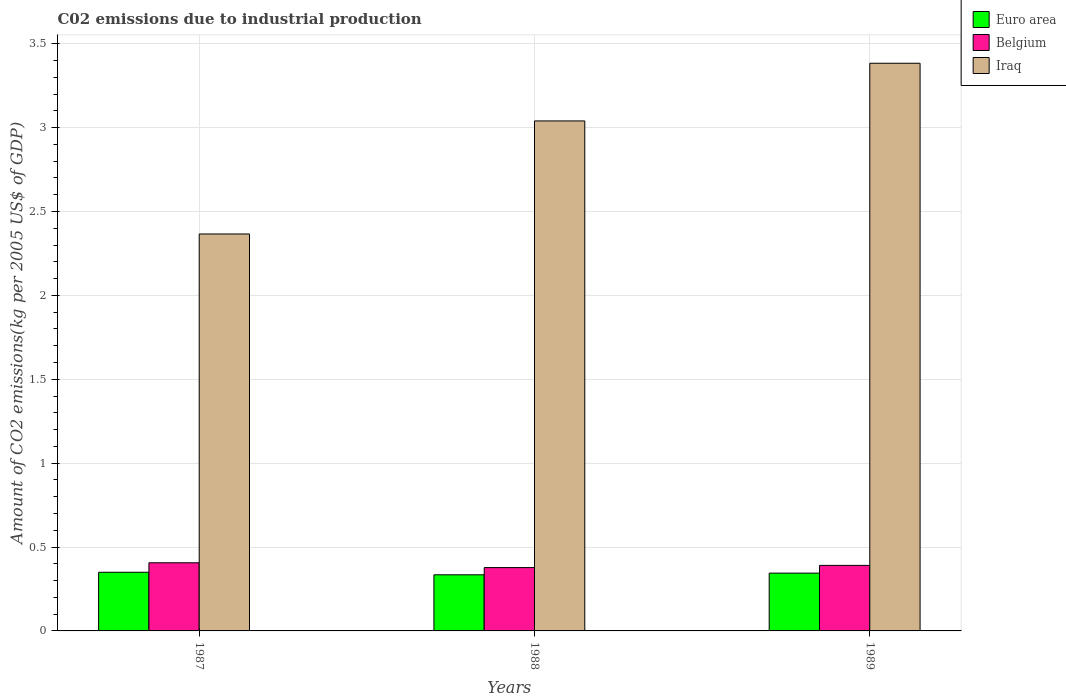Are the number of bars per tick equal to the number of legend labels?
Your response must be concise. Yes. In how many cases, is the number of bars for a given year not equal to the number of legend labels?
Provide a short and direct response. 0. What is the amount of CO2 emitted due to industrial production in Iraq in 1988?
Give a very brief answer. 3.04. Across all years, what is the maximum amount of CO2 emitted due to industrial production in Belgium?
Your answer should be very brief. 0.41. Across all years, what is the minimum amount of CO2 emitted due to industrial production in Iraq?
Provide a succinct answer. 2.37. In which year was the amount of CO2 emitted due to industrial production in Iraq maximum?
Ensure brevity in your answer.  1989. In which year was the amount of CO2 emitted due to industrial production in Iraq minimum?
Your response must be concise. 1987. What is the total amount of CO2 emitted due to industrial production in Belgium in the graph?
Your answer should be compact. 1.17. What is the difference between the amount of CO2 emitted due to industrial production in Iraq in 1987 and that in 1989?
Your response must be concise. -1.02. What is the difference between the amount of CO2 emitted due to industrial production in Iraq in 1988 and the amount of CO2 emitted due to industrial production in Belgium in 1989?
Keep it short and to the point. 2.65. What is the average amount of CO2 emitted due to industrial production in Belgium per year?
Your answer should be compact. 0.39. In the year 1988, what is the difference between the amount of CO2 emitted due to industrial production in Belgium and amount of CO2 emitted due to industrial production in Iraq?
Offer a terse response. -2.66. In how many years, is the amount of CO2 emitted due to industrial production in Iraq greater than 2.2 kg?
Ensure brevity in your answer.  3. What is the ratio of the amount of CO2 emitted due to industrial production in Belgium in 1987 to that in 1989?
Ensure brevity in your answer.  1.04. Is the difference between the amount of CO2 emitted due to industrial production in Belgium in 1988 and 1989 greater than the difference between the amount of CO2 emitted due to industrial production in Iraq in 1988 and 1989?
Provide a succinct answer. Yes. What is the difference between the highest and the second highest amount of CO2 emitted due to industrial production in Belgium?
Offer a terse response. 0.02. What is the difference between the highest and the lowest amount of CO2 emitted due to industrial production in Belgium?
Provide a succinct answer. 0.03. Is the sum of the amount of CO2 emitted due to industrial production in Iraq in 1988 and 1989 greater than the maximum amount of CO2 emitted due to industrial production in Belgium across all years?
Provide a succinct answer. Yes. What does the 3rd bar from the left in 1989 represents?
Offer a terse response. Iraq. What does the 1st bar from the right in 1989 represents?
Provide a short and direct response. Iraq. Is it the case that in every year, the sum of the amount of CO2 emitted due to industrial production in Euro area and amount of CO2 emitted due to industrial production in Belgium is greater than the amount of CO2 emitted due to industrial production in Iraq?
Your answer should be compact. No. How many bars are there?
Make the answer very short. 9. How many years are there in the graph?
Provide a succinct answer. 3. What is the difference between two consecutive major ticks on the Y-axis?
Make the answer very short. 0.5. Does the graph contain any zero values?
Offer a terse response. No. Does the graph contain grids?
Offer a very short reply. Yes. Where does the legend appear in the graph?
Your answer should be compact. Top right. How many legend labels are there?
Ensure brevity in your answer.  3. What is the title of the graph?
Your response must be concise. C02 emissions due to industrial production. Does "Trinidad and Tobago" appear as one of the legend labels in the graph?
Your response must be concise. No. What is the label or title of the Y-axis?
Keep it short and to the point. Amount of CO2 emissions(kg per 2005 US$ of GDP). What is the Amount of CO2 emissions(kg per 2005 US$ of GDP) of Euro area in 1987?
Provide a short and direct response. 0.35. What is the Amount of CO2 emissions(kg per 2005 US$ of GDP) in Belgium in 1987?
Provide a succinct answer. 0.41. What is the Amount of CO2 emissions(kg per 2005 US$ of GDP) in Iraq in 1987?
Give a very brief answer. 2.37. What is the Amount of CO2 emissions(kg per 2005 US$ of GDP) in Euro area in 1988?
Your response must be concise. 0.33. What is the Amount of CO2 emissions(kg per 2005 US$ of GDP) of Belgium in 1988?
Provide a short and direct response. 0.38. What is the Amount of CO2 emissions(kg per 2005 US$ of GDP) in Iraq in 1988?
Offer a terse response. 3.04. What is the Amount of CO2 emissions(kg per 2005 US$ of GDP) in Euro area in 1989?
Make the answer very short. 0.34. What is the Amount of CO2 emissions(kg per 2005 US$ of GDP) in Belgium in 1989?
Provide a succinct answer. 0.39. What is the Amount of CO2 emissions(kg per 2005 US$ of GDP) in Iraq in 1989?
Your response must be concise. 3.38. Across all years, what is the maximum Amount of CO2 emissions(kg per 2005 US$ of GDP) in Euro area?
Provide a short and direct response. 0.35. Across all years, what is the maximum Amount of CO2 emissions(kg per 2005 US$ of GDP) in Belgium?
Offer a terse response. 0.41. Across all years, what is the maximum Amount of CO2 emissions(kg per 2005 US$ of GDP) in Iraq?
Offer a very short reply. 3.38. Across all years, what is the minimum Amount of CO2 emissions(kg per 2005 US$ of GDP) in Euro area?
Keep it short and to the point. 0.33. Across all years, what is the minimum Amount of CO2 emissions(kg per 2005 US$ of GDP) of Belgium?
Your answer should be very brief. 0.38. Across all years, what is the minimum Amount of CO2 emissions(kg per 2005 US$ of GDP) in Iraq?
Provide a succinct answer. 2.37. What is the total Amount of CO2 emissions(kg per 2005 US$ of GDP) of Euro area in the graph?
Your answer should be compact. 1.03. What is the total Amount of CO2 emissions(kg per 2005 US$ of GDP) of Belgium in the graph?
Your answer should be compact. 1.17. What is the total Amount of CO2 emissions(kg per 2005 US$ of GDP) in Iraq in the graph?
Provide a succinct answer. 8.79. What is the difference between the Amount of CO2 emissions(kg per 2005 US$ of GDP) in Euro area in 1987 and that in 1988?
Your answer should be very brief. 0.02. What is the difference between the Amount of CO2 emissions(kg per 2005 US$ of GDP) of Belgium in 1987 and that in 1988?
Your answer should be very brief. 0.03. What is the difference between the Amount of CO2 emissions(kg per 2005 US$ of GDP) in Iraq in 1987 and that in 1988?
Provide a succinct answer. -0.67. What is the difference between the Amount of CO2 emissions(kg per 2005 US$ of GDP) in Euro area in 1987 and that in 1989?
Your response must be concise. 0.01. What is the difference between the Amount of CO2 emissions(kg per 2005 US$ of GDP) in Belgium in 1987 and that in 1989?
Your answer should be compact. 0.02. What is the difference between the Amount of CO2 emissions(kg per 2005 US$ of GDP) of Iraq in 1987 and that in 1989?
Your response must be concise. -1.02. What is the difference between the Amount of CO2 emissions(kg per 2005 US$ of GDP) in Euro area in 1988 and that in 1989?
Your answer should be compact. -0.01. What is the difference between the Amount of CO2 emissions(kg per 2005 US$ of GDP) in Belgium in 1988 and that in 1989?
Your answer should be compact. -0.01. What is the difference between the Amount of CO2 emissions(kg per 2005 US$ of GDP) of Iraq in 1988 and that in 1989?
Your response must be concise. -0.34. What is the difference between the Amount of CO2 emissions(kg per 2005 US$ of GDP) of Euro area in 1987 and the Amount of CO2 emissions(kg per 2005 US$ of GDP) of Belgium in 1988?
Offer a terse response. -0.03. What is the difference between the Amount of CO2 emissions(kg per 2005 US$ of GDP) in Euro area in 1987 and the Amount of CO2 emissions(kg per 2005 US$ of GDP) in Iraq in 1988?
Offer a very short reply. -2.69. What is the difference between the Amount of CO2 emissions(kg per 2005 US$ of GDP) in Belgium in 1987 and the Amount of CO2 emissions(kg per 2005 US$ of GDP) in Iraq in 1988?
Your answer should be very brief. -2.63. What is the difference between the Amount of CO2 emissions(kg per 2005 US$ of GDP) in Euro area in 1987 and the Amount of CO2 emissions(kg per 2005 US$ of GDP) in Belgium in 1989?
Make the answer very short. -0.04. What is the difference between the Amount of CO2 emissions(kg per 2005 US$ of GDP) in Euro area in 1987 and the Amount of CO2 emissions(kg per 2005 US$ of GDP) in Iraq in 1989?
Provide a succinct answer. -3.03. What is the difference between the Amount of CO2 emissions(kg per 2005 US$ of GDP) of Belgium in 1987 and the Amount of CO2 emissions(kg per 2005 US$ of GDP) of Iraq in 1989?
Your answer should be compact. -2.98. What is the difference between the Amount of CO2 emissions(kg per 2005 US$ of GDP) in Euro area in 1988 and the Amount of CO2 emissions(kg per 2005 US$ of GDP) in Belgium in 1989?
Provide a short and direct response. -0.06. What is the difference between the Amount of CO2 emissions(kg per 2005 US$ of GDP) in Euro area in 1988 and the Amount of CO2 emissions(kg per 2005 US$ of GDP) in Iraq in 1989?
Provide a succinct answer. -3.05. What is the difference between the Amount of CO2 emissions(kg per 2005 US$ of GDP) of Belgium in 1988 and the Amount of CO2 emissions(kg per 2005 US$ of GDP) of Iraq in 1989?
Make the answer very short. -3.01. What is the average Amount of CO2 emissions(kg per 2005 US$ of GDP) in Euro area per year?
Your answer should be compact. 0.34. What is the average Amount of CO2 emissions(kg per 2005 US$ of GDP) of Belgium per year?
Your response must be concise. 0.39. What is the average Amount of CO2 emissions(kg per 2005 US$ of GDP) in Iraq per year?
Keep it short and to the point. 2.93. In the year 1987, what is the difference between the Amount of CO2 emissions(kg per 2005 US$ of GDP) in Euro area and Amount of CO2 emissions(kg per 2005 US$ of GDP) in Belgium?
Your answer should be very brief. -0.06. In the year 1987, what is the difference between the Amount of CO2 emissions(kg per 2005 US$ of GDP) in Euro area and Amount of CO2 emissions(kg per 2005 US$ of GDP) in Iraq?
Provide a short and direct response. -2.02. In the year 1987, what is the difference between the Amount of CO2 emissions(kg per 2005 US$ of GDP) of Belgium and Amount of CO2 emissions(kg per 2005 US$ of GDP) of Iraq?
Your answer should be compact. -1.96. In the year 1988, what is the difference between the Amount of CO2 emissions(kg per 2005 US$ of GDP) in Euro area and Amount of CO2 emissions(kg per 2005 US$ of GDP) in Belgium?
Keep it short and to the point. -0.04. In the year 1988, what is the difference between the Amount of CO2 emissions(kg per 2005 US$ of GDP) of Euro area and Amount of CO2 emissions(kg per 2005 US$ of GDP) of Iraq?
Offer a terse response. -2.71. In the year 1988, what is the difference between the Amount of CO2 emissions(kg per 2005 US$ of GDP) of Belgium and Amount of CO2 emissions(kg per 2005 US$ of GDP) of Iraq?
Your answer should be very brief. -2.66. In the year 1989, what is the difference between the Amount of CO2 emissions(kg per 2005 US$ of GDP) of Euro area and Amount of CO2 emissions(kg per 2005 US$ of GDP) of Belgium?
Provide a succinct answer. -0.05. In the year 1989, what is the difference between the Amount of CO2 emissions(kg per 2005 US$ of GDP) of Euro area and Amount of CO2 emissions(kg per 2005 US$ of GDP) of Iraq?
Provide a succinct answer. -3.04. In the year 1989, what is the difference between the Amount of CO2 emissions(kg per 2005 US$ of GDP) of Belgium and Amount of CO2 emissions(kg per 2005 US$ of GDP) of Iraq?
Offer a terse response. -2.99. What is the ratio of the Amount of CO2 emissions(kg per 2005 US$ of GDP) of Euro area in 1987 to that in 1988?
Ensure brevity in your answer.  1.05. What is the ratio of the Amount of CO2 emissions(kg per 2005 US$ of GDP) of Belgium in 1987 to that in 1988?
Your answer should be very brief. 1.08. What is the ratio of the Amount of CO2 emissions(kg per 2005 US$ of GDP) in Iraq in 1987 to that in 1988?
Provide a short and direct response. 0.78. What is the ratio of the Amount of CO2 emissions(kg per 2005 US$ of GDP) in Euro area in 1987 to that in 1989?
Offer a terse response. 1.01. What is the ratio of the Amount of CO2 emissions(kg per 2005 US$ of GDP) in Belgium in 1987 to that in 1989?
Keep it short and to the point. 1.04. What is the ratio of the Amount of CO2 emissions(kg per 2005 US$ of GDP) of Iraq in 1987 to that in 1989?
Give a very brief answer. 0.7. What is the ratio of the Amount of CO2 emissions(kg per 2005 US$ of GDP) of Euro area in 1988 to that in 1989?
Offer a very short reply. 0.97. What is the ratio of the Amount of CO2 emissions(kg per 2005 US$ of GDP) in Belgium in 1988 to that in 1989?
Your response must be concise. 0.97. What is the ratio of the Amount of CO2 emissions(kg per 2005 US$ of GDP) in Iraq in 1988 to that in 1989?
Provide a succinct answer. 0.9. What is the difference between the highest and the second highest Amount of CO2 emissions(kg per 2005 US$ of GDP) of Euro area?
Offer a very short reply. 0.01. What is the difference between the highest and the second highest Amount of CO2 emissions(kg per 2005 US$ of GDP) of Belgium?
Ensure brevity in your answer.  0.02. What is the difference between the highest and the second highest Amount of CO2 emissions(kg per 2005 US$ of GDP) in Iraq?
Ensure brevity in your answer.  0.34. What is the difference between the highest and the lowest Amount of CO2 emissions(kg per 2005 US$ of GDP) of Euro area?
Your answer should be compact. 0.02. What is the difference between the highest and the lowest Amount of CO2 emissions(kg per 2005 US$ of GDP) of Belgium?
Give a very brief answer. 0.03. What is the difference between the highest and the lowest Amount of CO2 emissions(kg per 2005 US$ of GDP) of Iraq?
Provide a short and direct response. 1.02. 